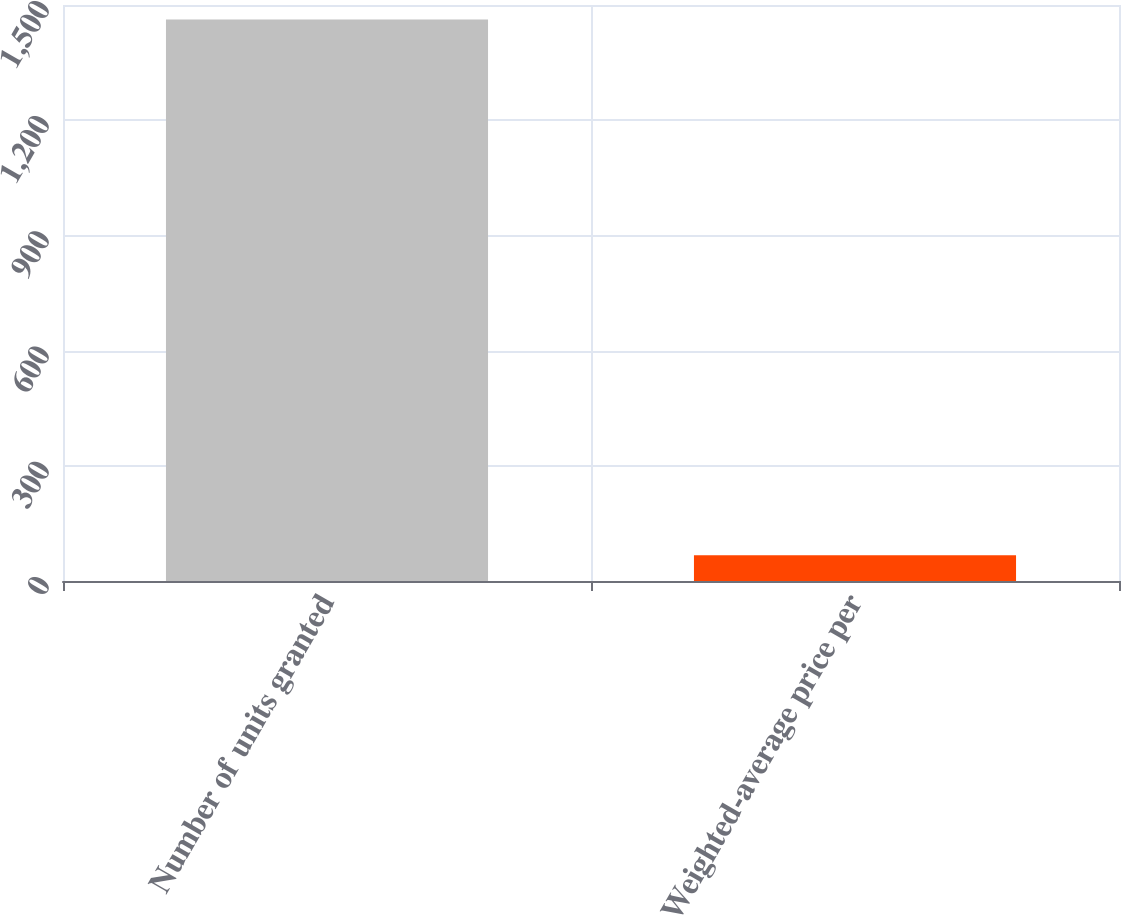Convert chart. <chart><loc_0><loc_0><loc_500><loc_500><bar_chart><fcel>Number of units granted<fcel>Weighted-average price per<nl><fcel>1462.3<fcel>67.01<nl></chart> 